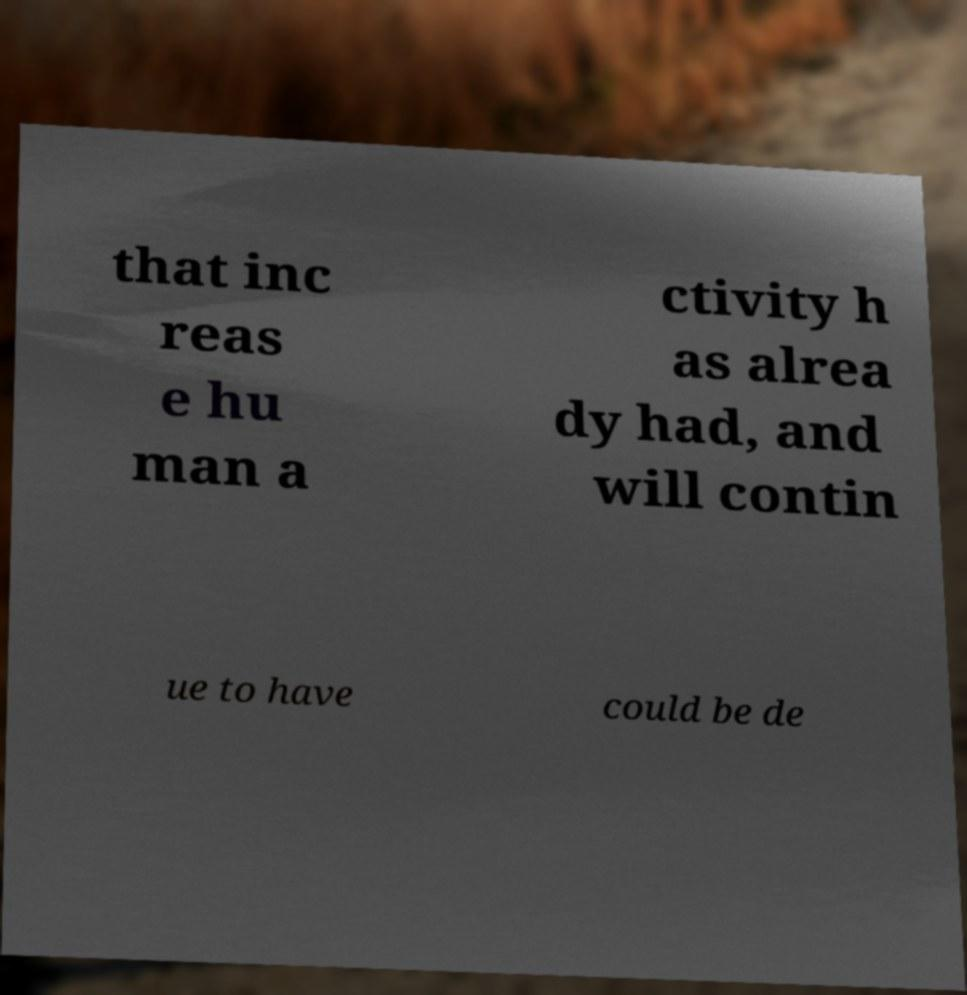Can you read and provide the text displayed in the image?This photo seems to have some interesting text. Can you extract and type it out for me? that inc reas e hu man a ctivity h as alrea dy had, and will contin ue to have could be de 